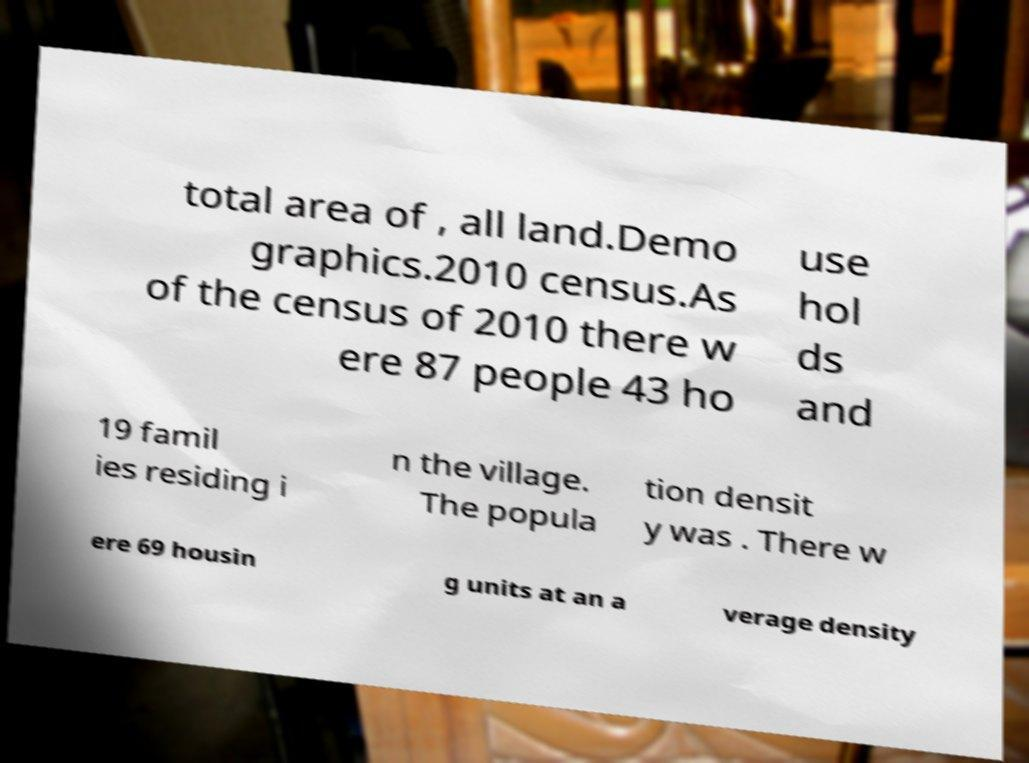I need the written content from this picture converted into text. Can you do that? total area of , all land.Demo graphics.2010 census.As of the census of 2010 there w ere 87 people 43 ho use hol ds and 19 famil ies residing i n the village. The popula tion densit y was . There w ere 69 housin g units at an a verage density 